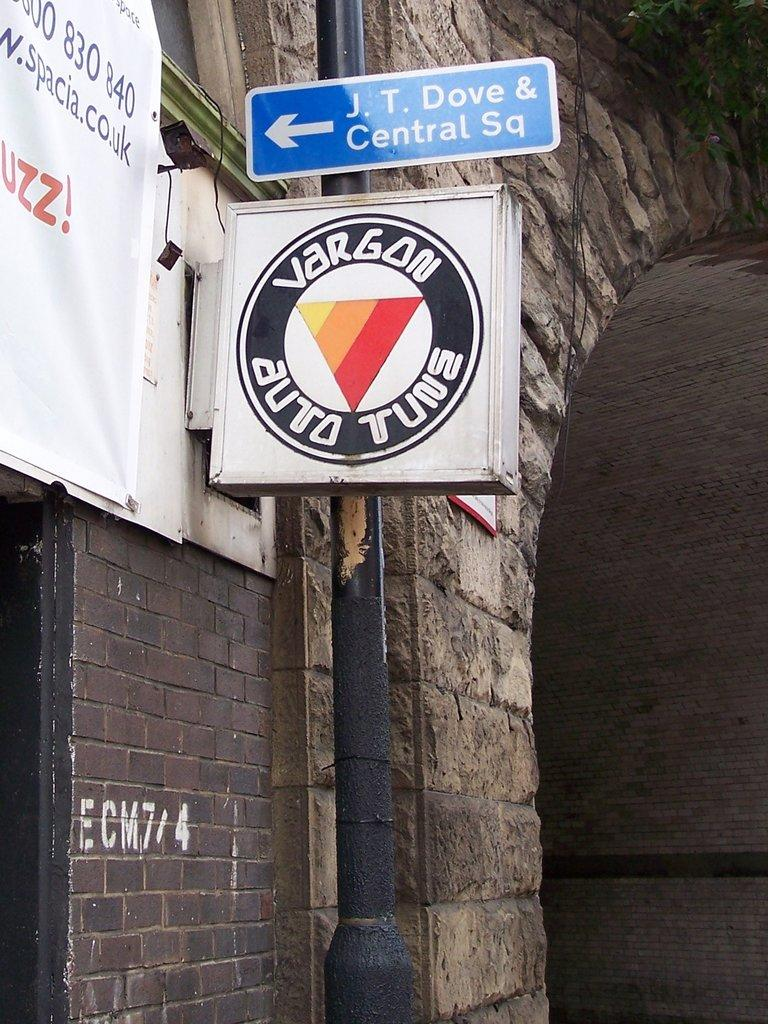<image>
Summarize the visual content of the image. The sign for Vargon Auto Tune is on the side of a building. 